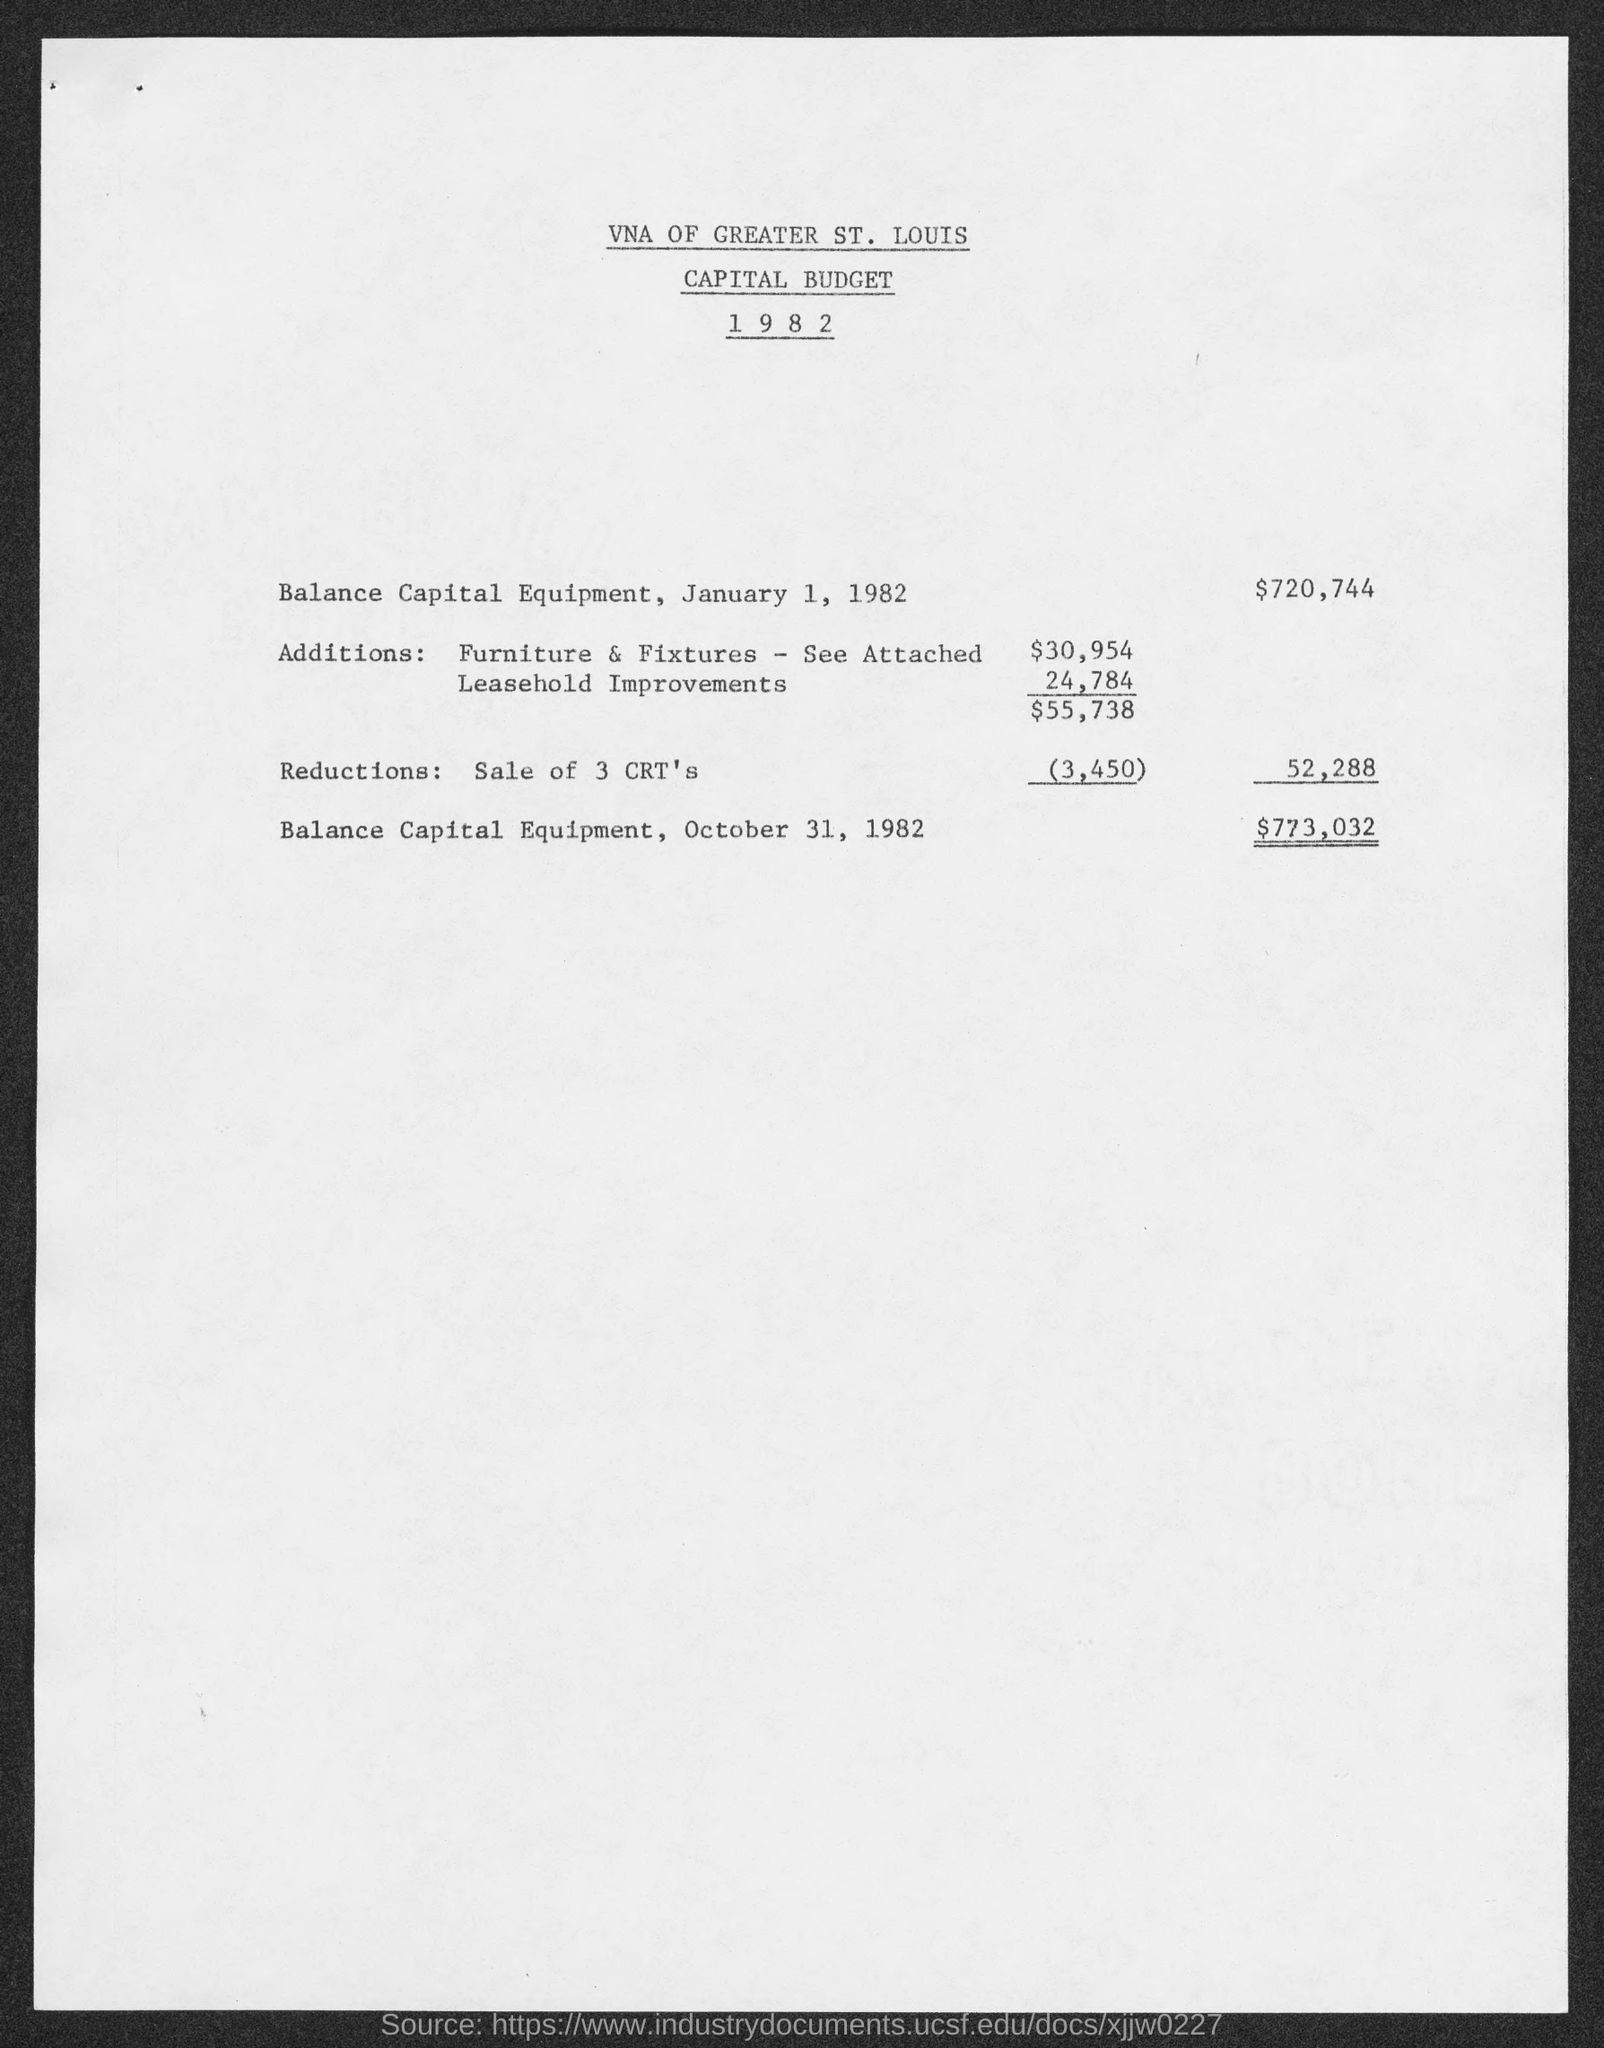What is the Balance Capital Equipment, January 1, 1982?
Your response must be concise. $720,744. What is the document about?
Provide a succinct answer. CAPITAL BUDGET. 